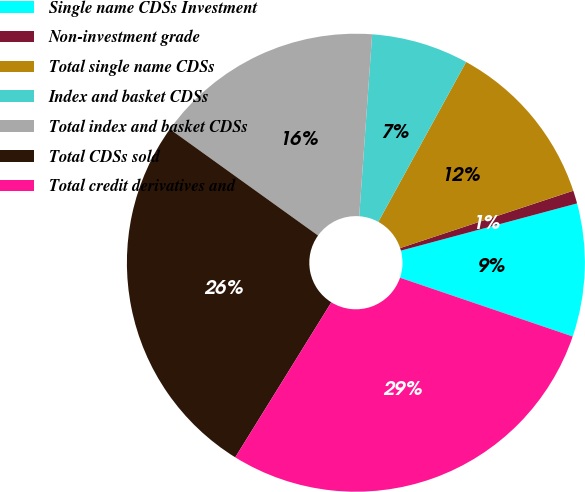Convert chart. <chart><loc_0><loc_0><loc_500><loc_500><pie_chart><fcel>Single name CDSs Investment<fcel>Non-investment grade<fcel>Total single name CDSs<fcel>Index and basket CDSs<fcel>Total index and basket CDSs<fcel>Total CDSs sold<fcel>Total credit derivatives and<nl><fcel>9.39%<fcel>0.92%<fcel>11.92%<fcel>6.86%<fcel>16.22%<fcel>26.08%<fcel>28.61%<nl></chart> 